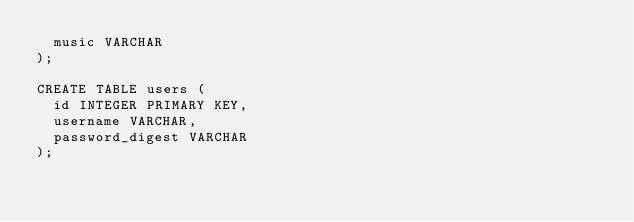<code> <loc_0><loc_0><loc_500><loc_500><_SQL_>  music VARCHAR
);

CREATE TABLE users (
  id INTEGER PRIMARY KEY,
  username VARCHAR,
  password_digest VARCHAR
);</code> 